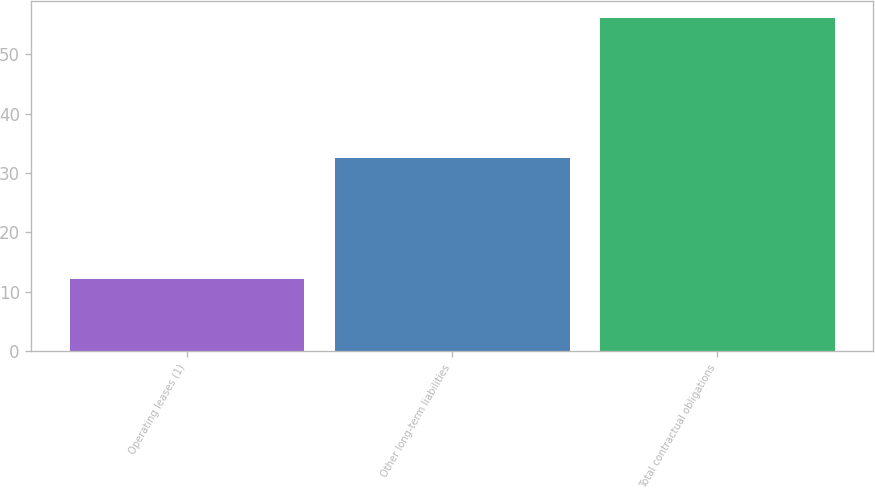Convert chart. <chart><loc_0><loc_0><loc_500><loc_500><bar_chart><fcel>Operating leases (1)<fcel>Other long-term liabilities<fcel>Total contractual obligations<nl><fcel>12.2<fcel>32.5<fcel>56.2<nl></chart> 